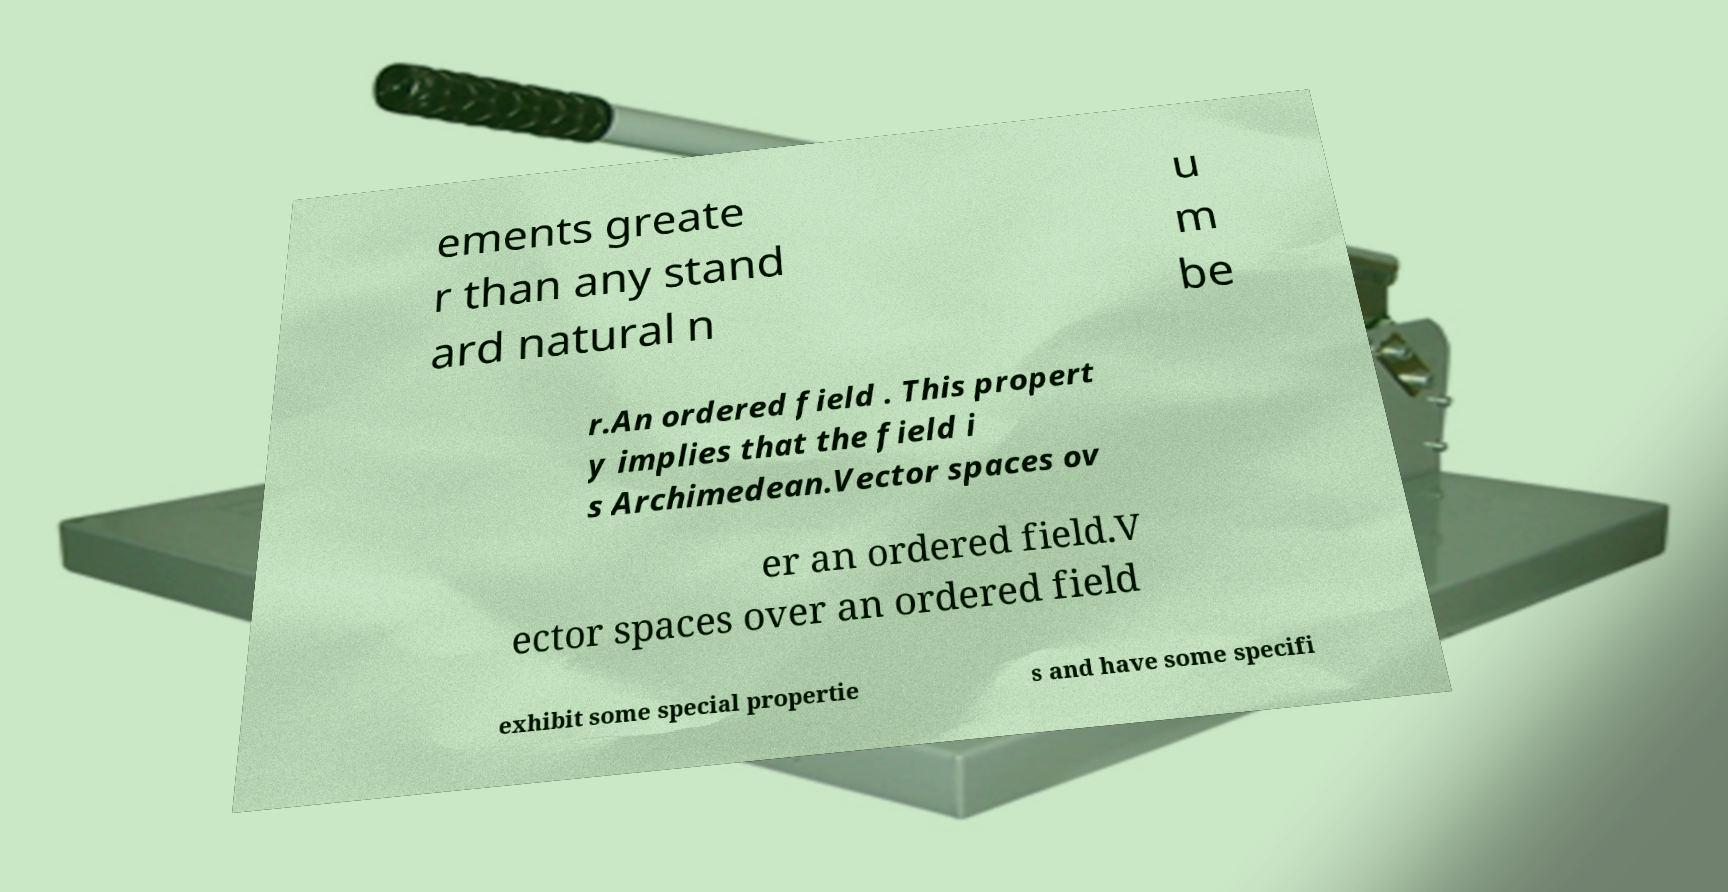Could you extract and type out the text from this image? ements greate r than any stand ard natural n u m be r.An ordered field . This propert y implies that the field i s Archimedean.Vector spaces ov er an ordered field.V ector spaces over an ordered field exhibit some special propertie s and have some specifi 